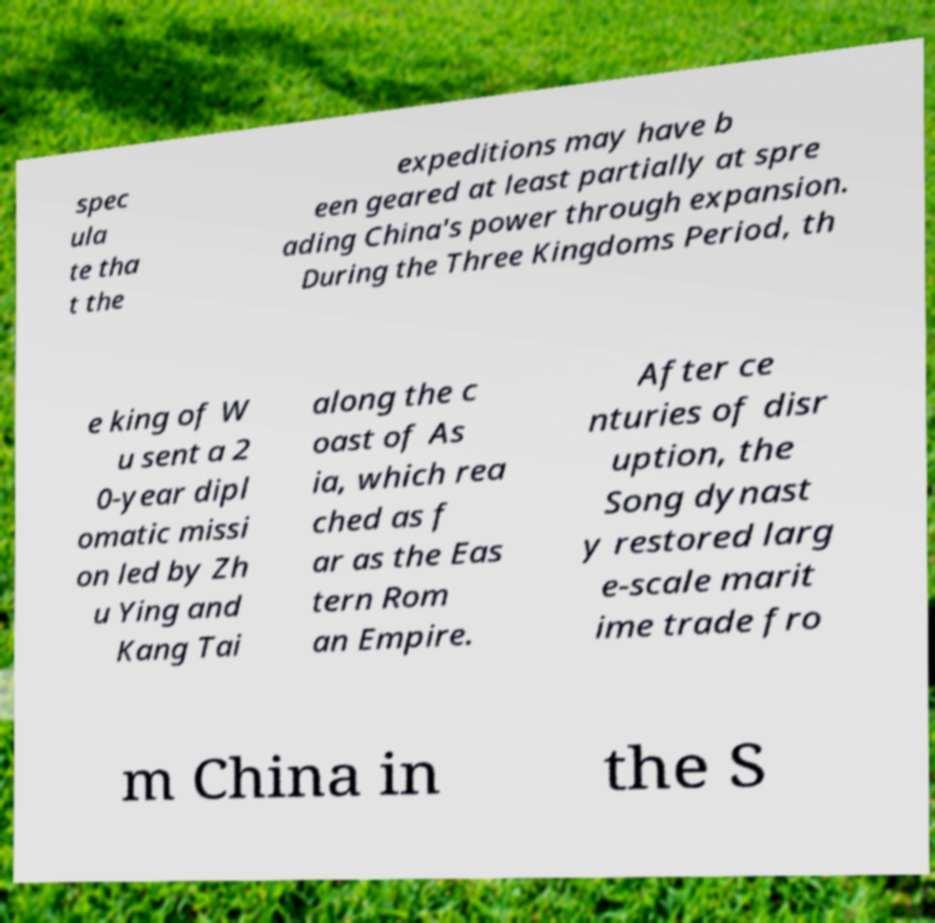I need the written content from this picture converted into text. Can you do that? spec ula te tha t the expeditions may have b een geared at least partially at spre ading China's power through expansion. During the Three Kingdoms Period, th e king of W u sent a 2 0-year dipl omatic missi on led by Zh u Ying and Kang Tai along the c oast of As ia, which rea ched as f ar as the Eas tern Rom an Empire. After ce nturies of disr uption, the Song dynast y restored larg e-scale marit ime trade fro m China in the S 